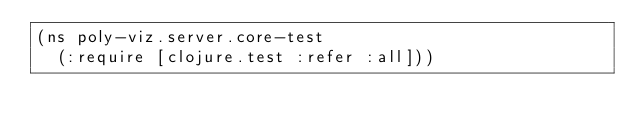<code> <loc_0><loc_0><loc_500><loc_500><_Clojure_>(ns poly-viz.server.core-test
  (:require [clojure.test :refer :all]))
</code> 